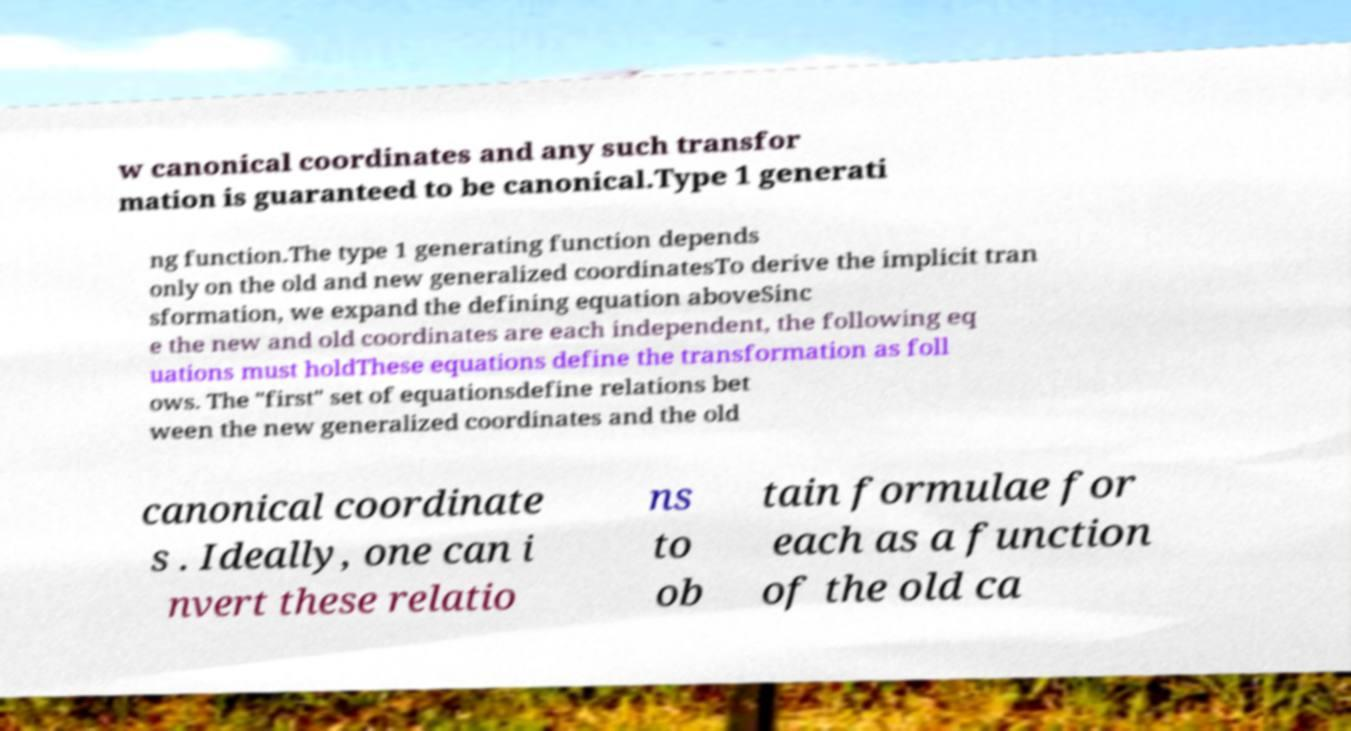Please read and relay the text visible in this image. What does it say? w canonical coordinates and any such transfor mation is guaranteed to be canonical.Type 1 generati ng function.The type 1 generating function depends only on the old and new generalized coordinatesTo derive the implicit tran sformation, we expand the defining equation aboveSinc e the new and old coordinates are each independent, the following eq uations must holdThese equations define the transformation as foll ows. The "first" set of equationsdefine relations bet ween the new generalized coordinates and the old canonical coordinate s . Ideally, one can i nvert these relatio ns to ob tain formulae for each as a function of the old ca 